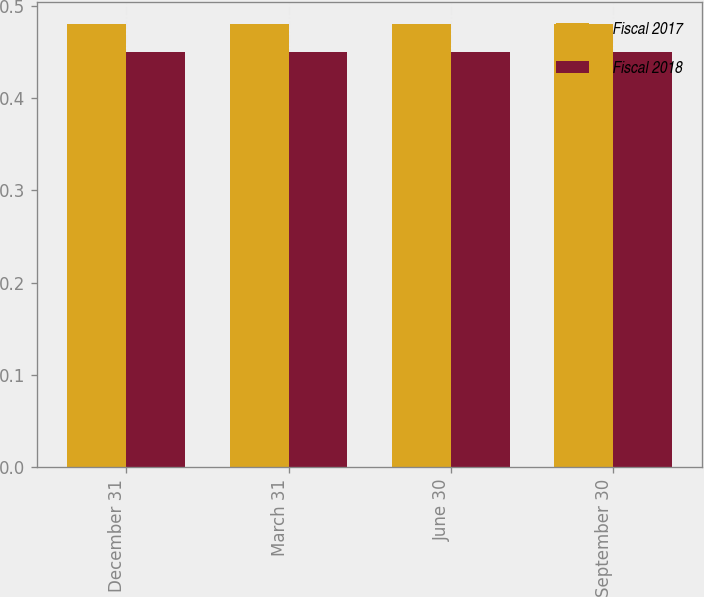Convert chart. <chart><loc_0><loc_0><loc_500><loc_500><stacked_bar_chart><ecel><fcel>December 31<fcel>March 31<fcel>June 30<fcel>September 30<nl><fcel>Fiscal 2017<fcel>0.48<fcel>0.48<fcel>0.48<fcel>0.48<nl><fcel>Fiscal 2018<fcel>0.45<fcel>0.45<fcel>0.45<fcel>0.45<nl></chart> 